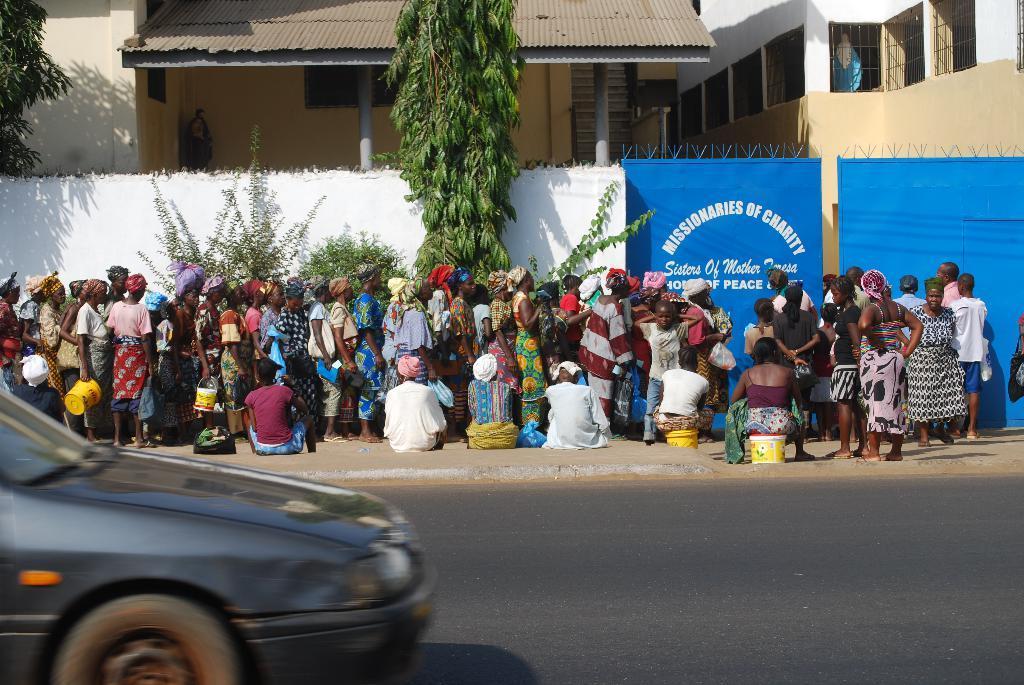Describe this image in one or two sentences. In this picture there are group of people standing and there are group of people sitting on the footpath and there are boards and there is text on the board and there are buildings and trees and there are plants. In the foreground there is a vehicle on the road. 